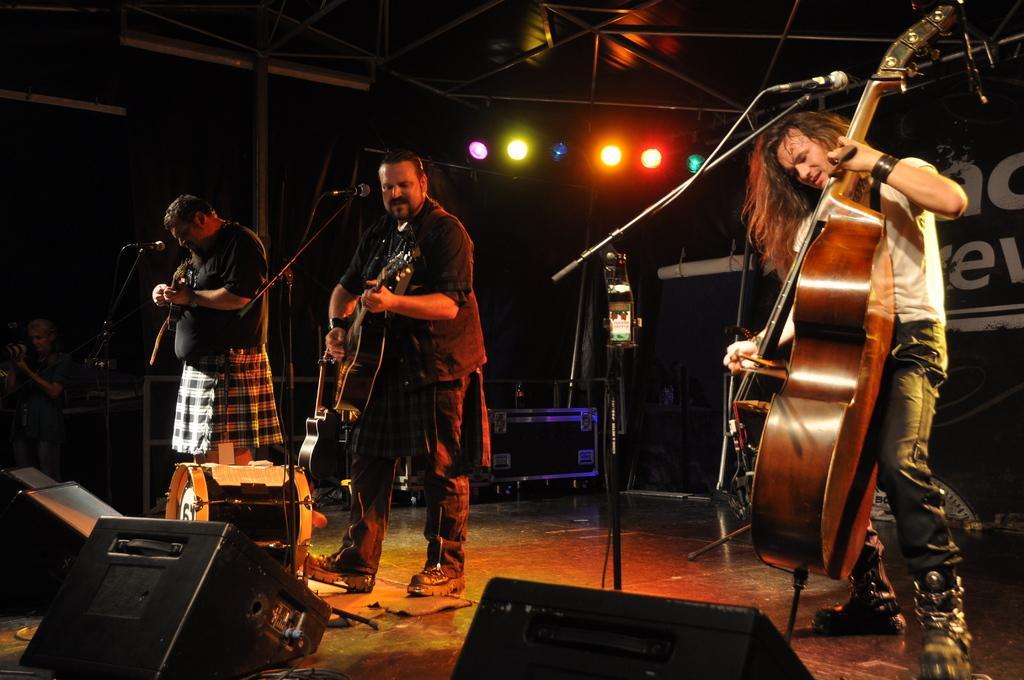Please provide a concise description of this image. In this image, there are three persons wearing clothes and standing in front of mics. The person who is on the right side of picture playing a musical instrument. There is a person in the center of this image playing a guitar. There are three speaker at the bottom of this picture. There are some lights at the top. 